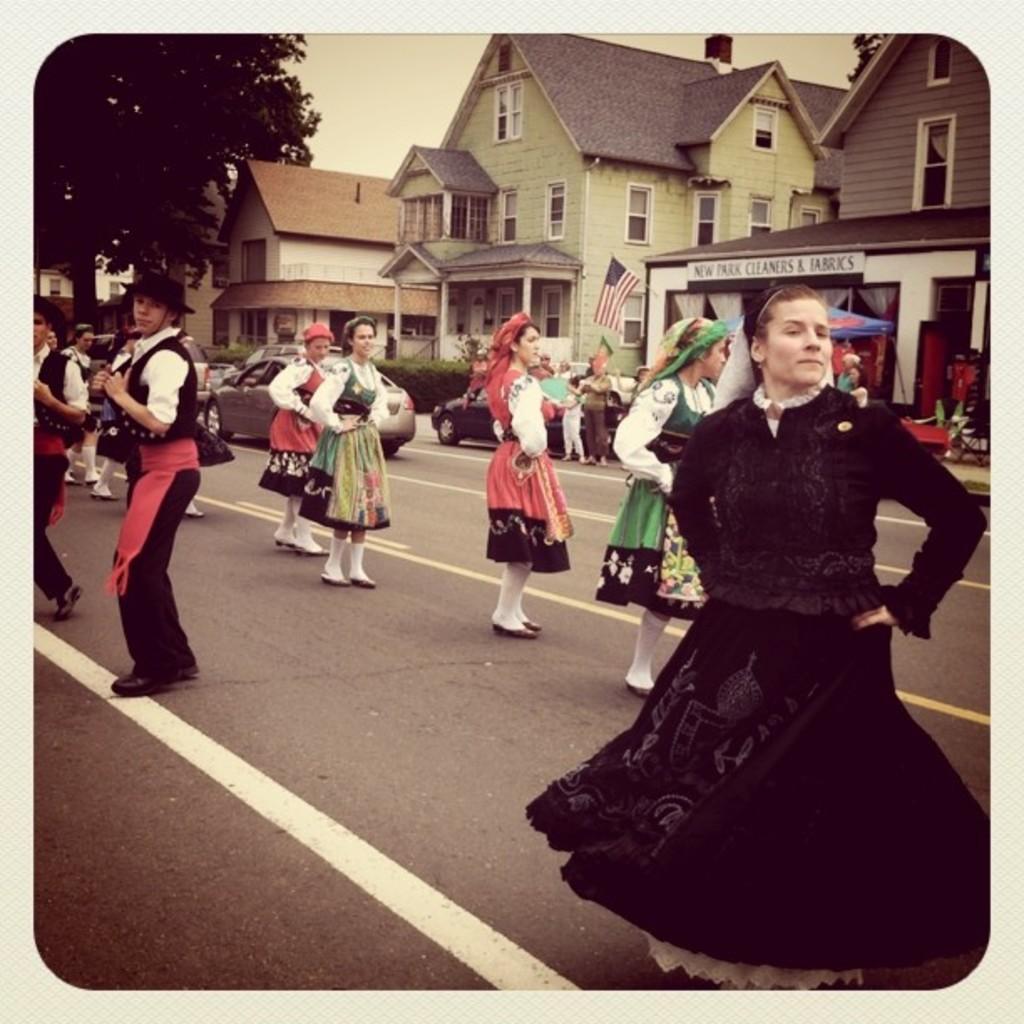Please provide a concise description of this image. In this image we can see a photograph on a album page. In the photo we can see few persons are dancing on the road, vehicles, buildings, windows, tree, flag, objects and sky. 